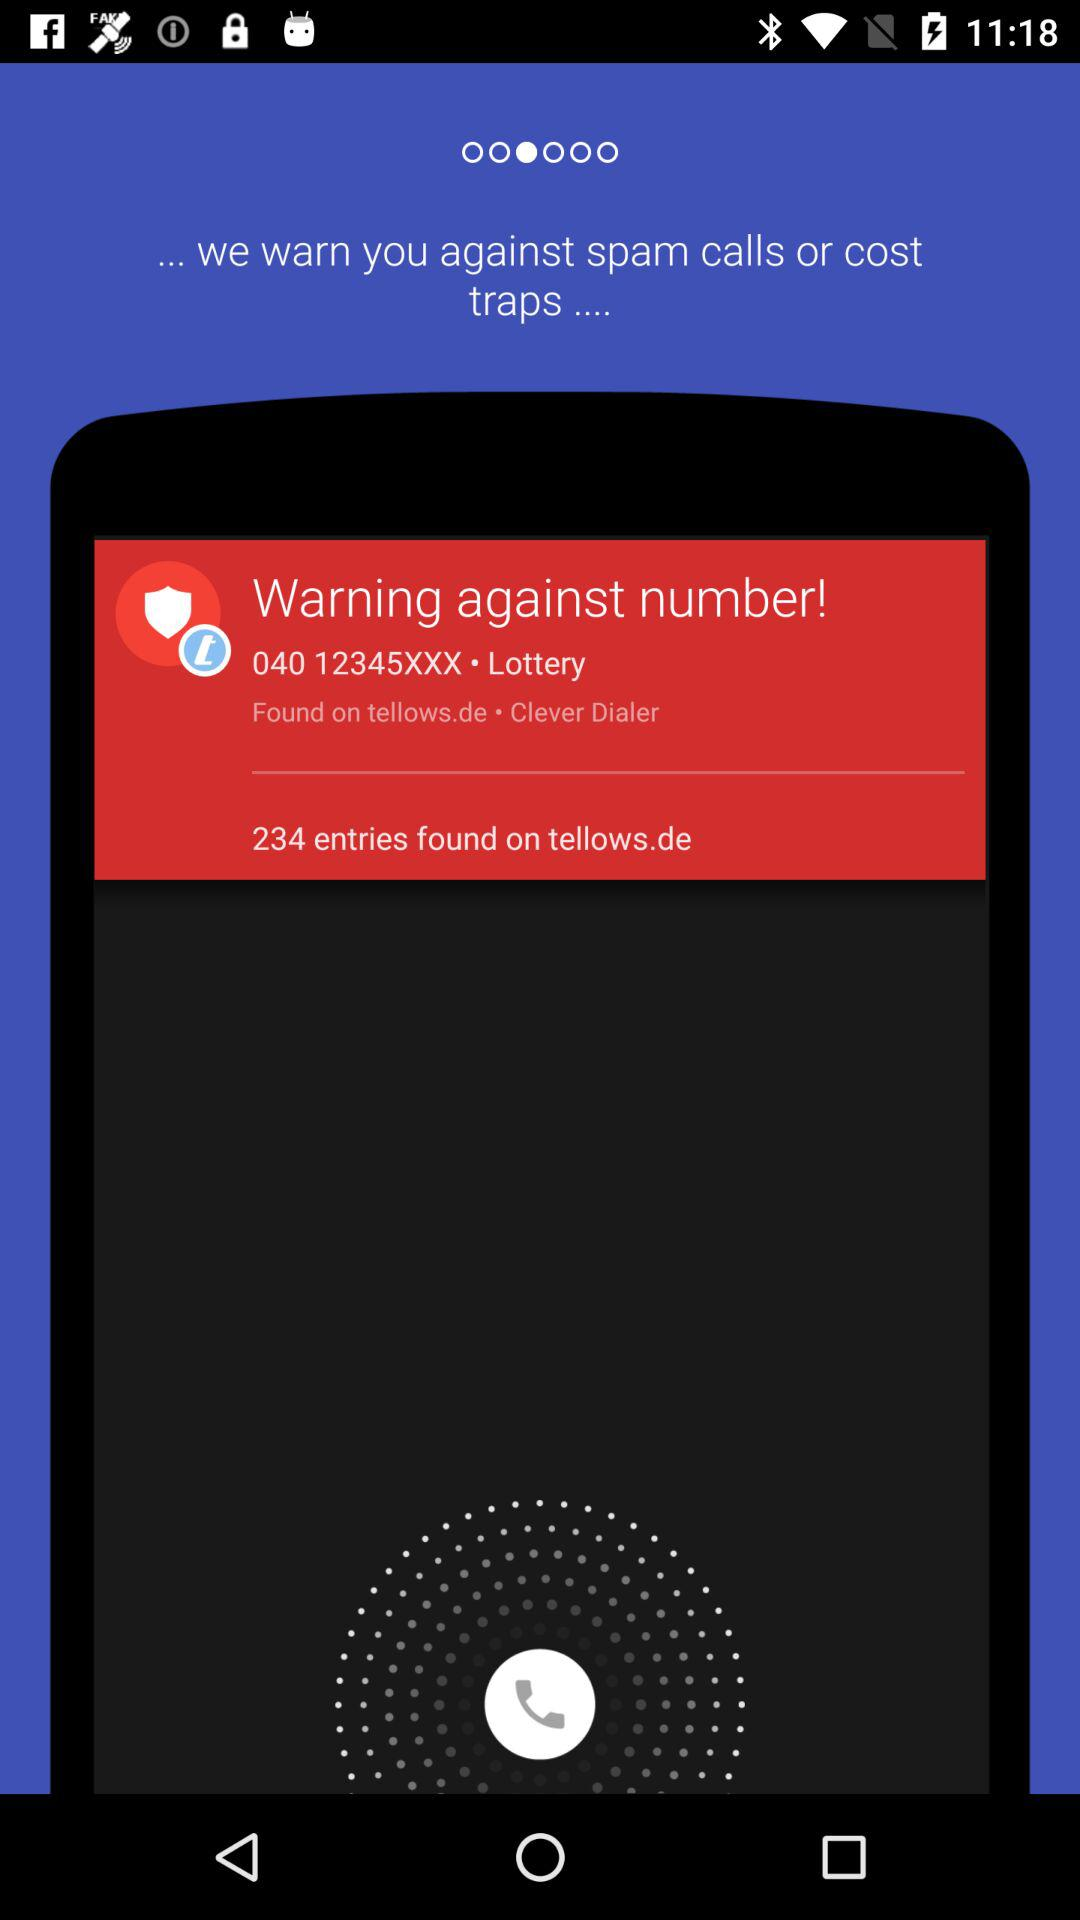How many entries are found? There are 234 entries found. 